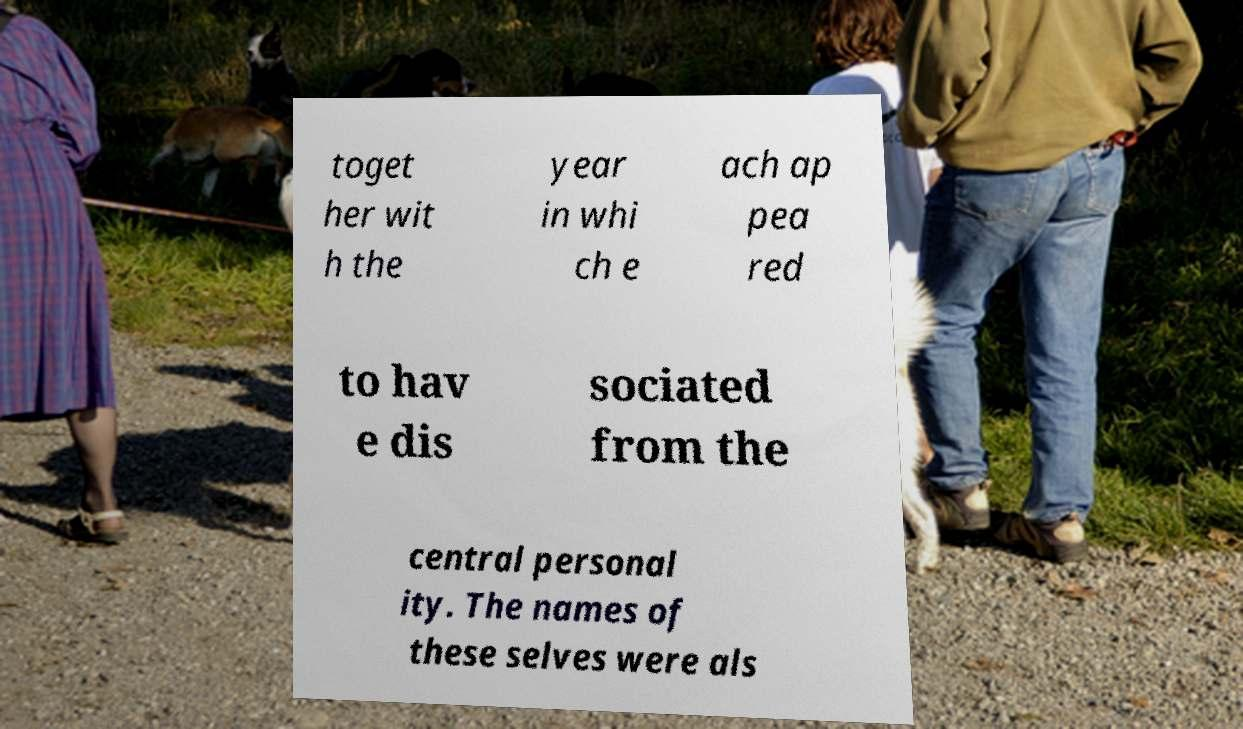Could you extract and type out the text from this image? toget her wit h the year in whi ch e ach ap pea red to hav e dis sociated from the central personal ity. The names of these selves were als 